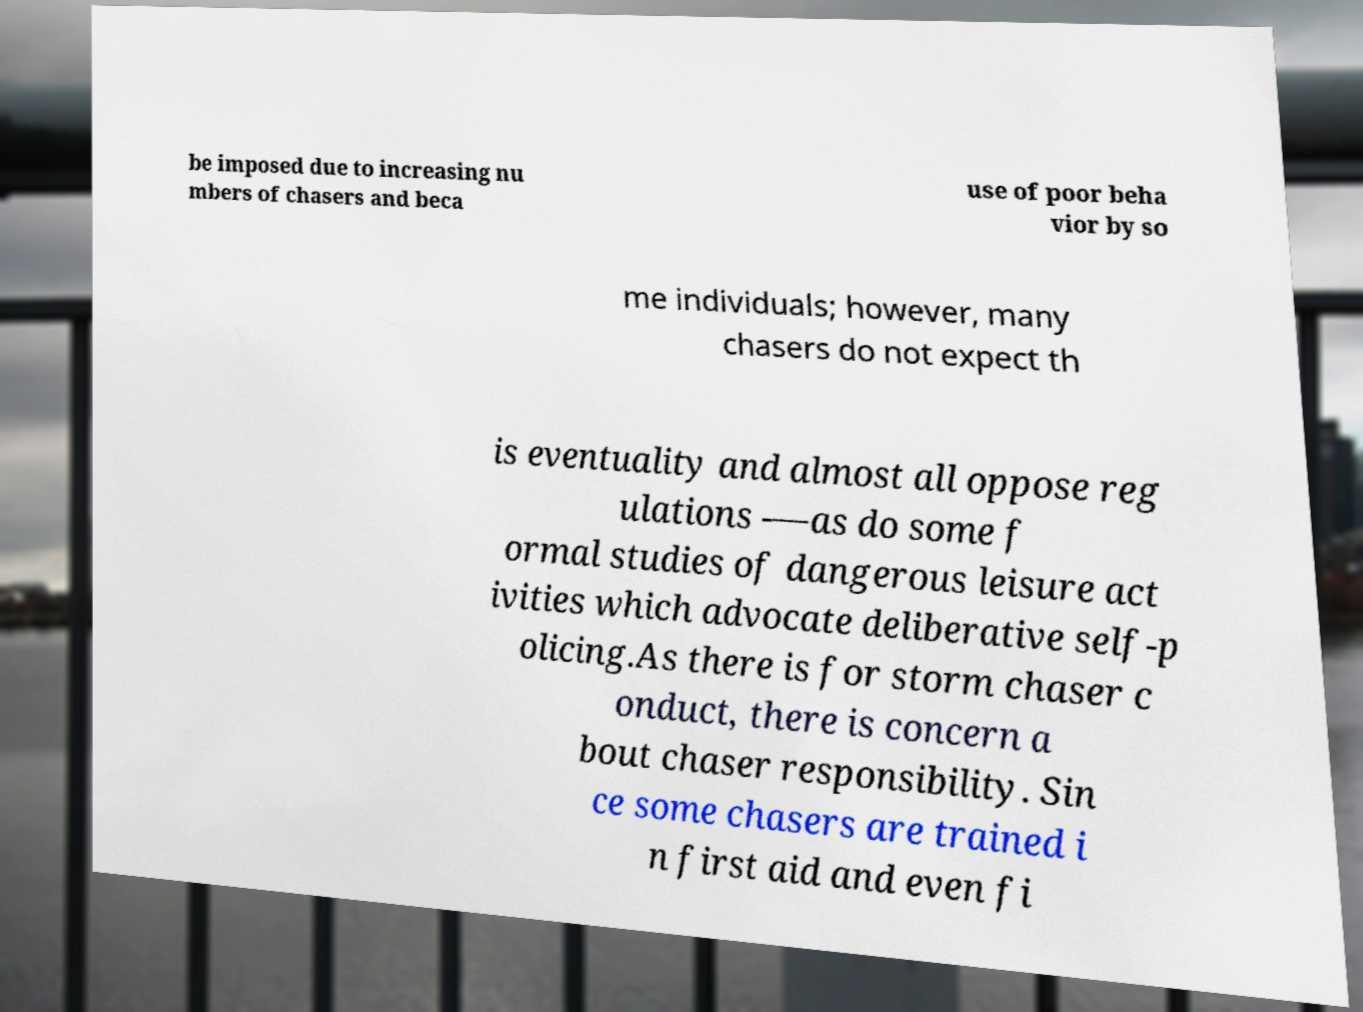For documentation purposes, I need the text within this image transcribed. Could you provide that? be imposed due to increasing nu mbers of chasers and beca use of poor beha vior by so me individuals; however, many chasers do not expect th is eventuality and almost all oppose reg ulations -—as do some f ormal studies of dangerous leisure act ivities which advocate deliberative self-p olicing.As there is for storm chaser c onduct, there is concern a bout chaser responsibility. Sin ce some chasers are trained i n first aid and even fi 